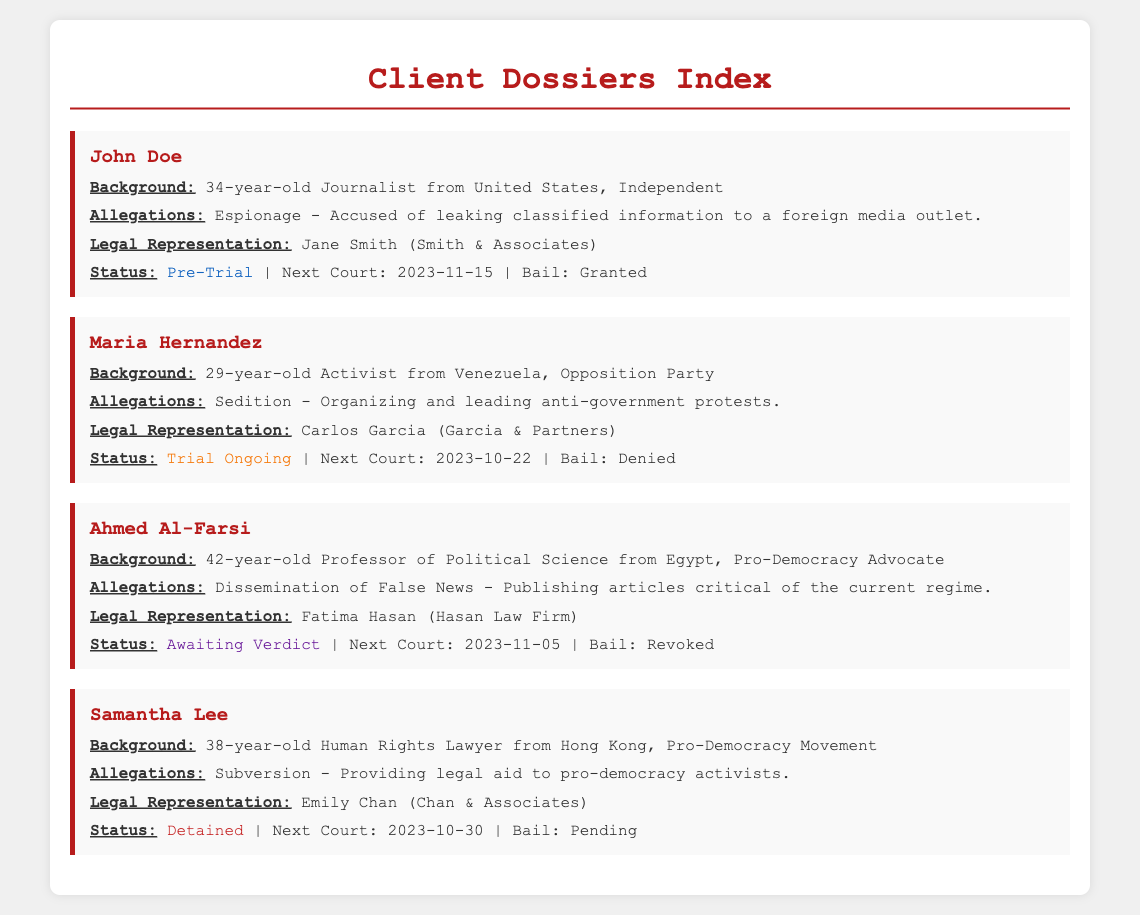What is the age of John Doe? John Doe is described as a 34-year-old in the background section of his dossier.
Answer: 34 What is the next court date for Maria Hernandez? The document states that the next court date for Maria Hernandez is 2023-10-22.
Answer: 2023-10-22 Who represents Ahmed Al-Farsi? The legal representation section specifies that Ahmed Al-Farsi is represented by Fatima Hasan from Hasan Law Firm.
Answer: Fatima Hasan (Hasan Law Firm) What are the allegations against Samantha Lee? The document lists that the allegations against Samantha Lee are "Subversion - Providing legal aid to pro-democracy activists."
Answer: Subversion - Providing legal aid to pro-democracy activists What is the status of John Doe's case? The status section indicates that John Doe's case is currently "Pre-Trial."
Answer: Pre-Trial Which client has their bail granted? The bail status for John Doe indicates that it has been granted, which is specified in his status section.
Answer: Granted What is the main theme of allegations against Maria Hernandez? The document states that the theme of allegations against Maria Hernandez relates to organizing and leading anti-government protests, implying a focus on political dissent.
Answer: Sedition What is the legal representation status of clients currently detained? The document details that Samantha Lee is currently detained, indicating the legal representation status for her as well.
Answer: Emily Chan (Chan & Associates) How many clients are awaiting verdicts? By reviewing the document, it is evident that there is one client (Ahmed Al-Farsi) awaiting a verdict.
Answer: 1 